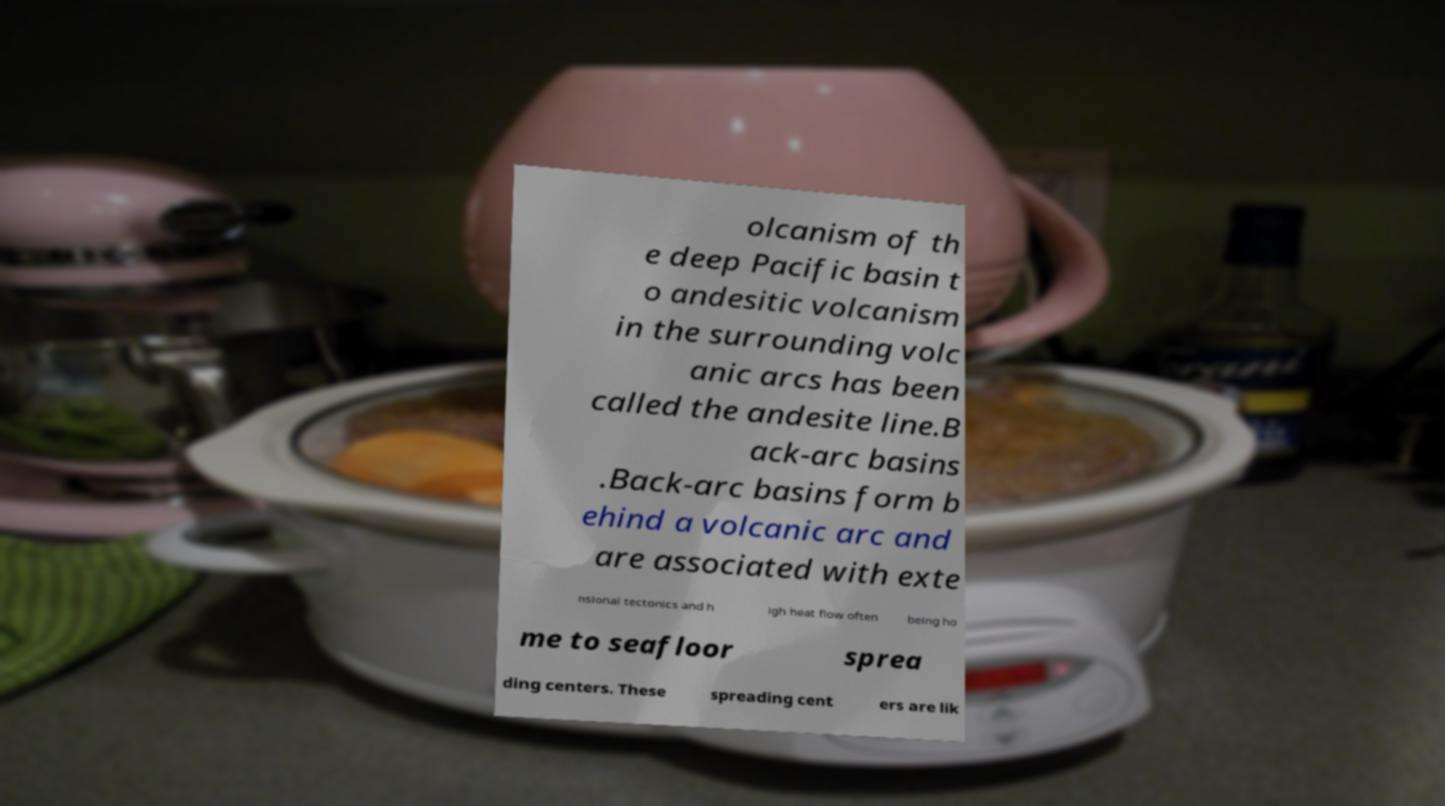What messages or text are displayed in this image? I need them in a readable, typed format. olcanism of th e deep Pacific basin t o andesitic volcanism in the surrounding volc anic arcs has been called the andesite line.B ack-arc basins .Back-arc basins form b ehind a volcanic arc and are associated with exte nsional tectonics and h igh heat flow often being ho me to seafloor sprea ding centers. These spreading cent ers are lik 